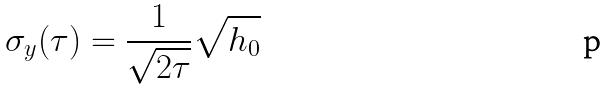Convert formula to latex. <formula><loc_0><loc_0><loc_500><loc_500>\sigma _ { y } ( \tau ) = \frac { 1 } { \sqrt { 2 \tau } } \sqrt { h _ { 0 } }</formula> 